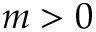Convert formula to latex. <formula><loc_0><loc_0><loc_500><loc_500>m > 0</formula> 